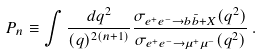<formula> <loc_0><loc_0><loc_500><loc_500>P _ { n } \equiv \int \frac { d q ^ { 2 } } { ( q ) ^ { 2 ( n + 1 ) } } \frac { \sigma _ { e ^ { + } e ^ { - } \to b \bar { b } + X } ( q ^ { 2 } ) } { \sigma _ { e ^ { + } e ^ { - } \to \mu ^ { + } \mu ^ { - } } ( q ^ { 2 } ) } \, .</formula> 